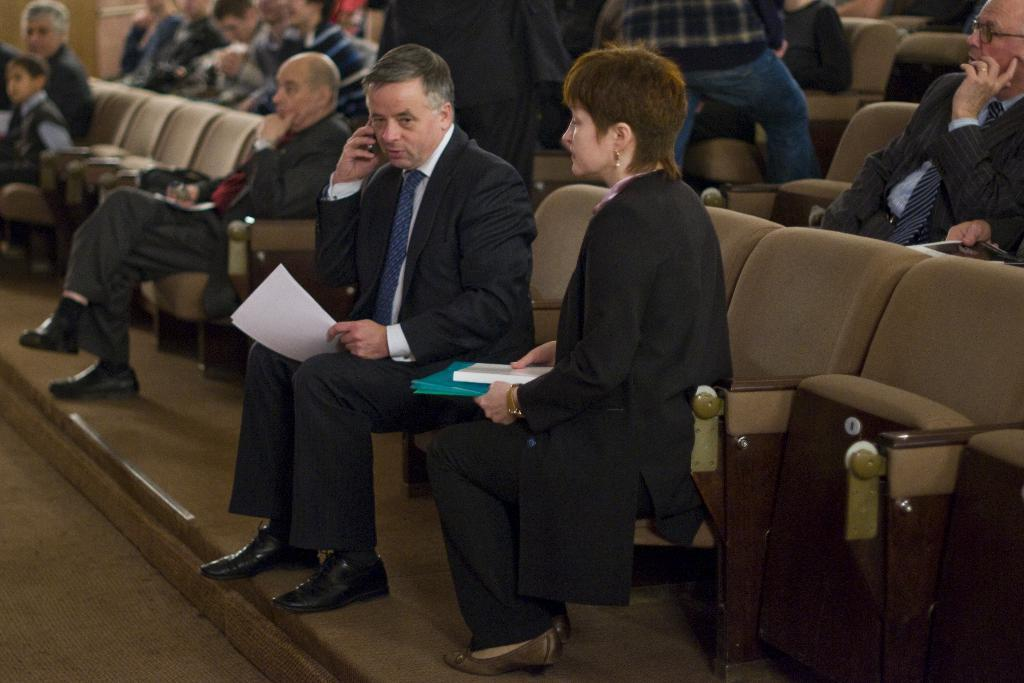How many people are in the image? There is a group of people in the image. What are the people in the image doing? The people are sitting. However, the specific detail about them sitting on a chair is unclear and may not be accurate. What type of rake is being used by the people in the image? There is no rake present in the image. Can you tell me how many airports are visible in the image? There are no airports visible in the image. What kind of linen is draped over the people in the image? There is no linen draped over the people in the image. 